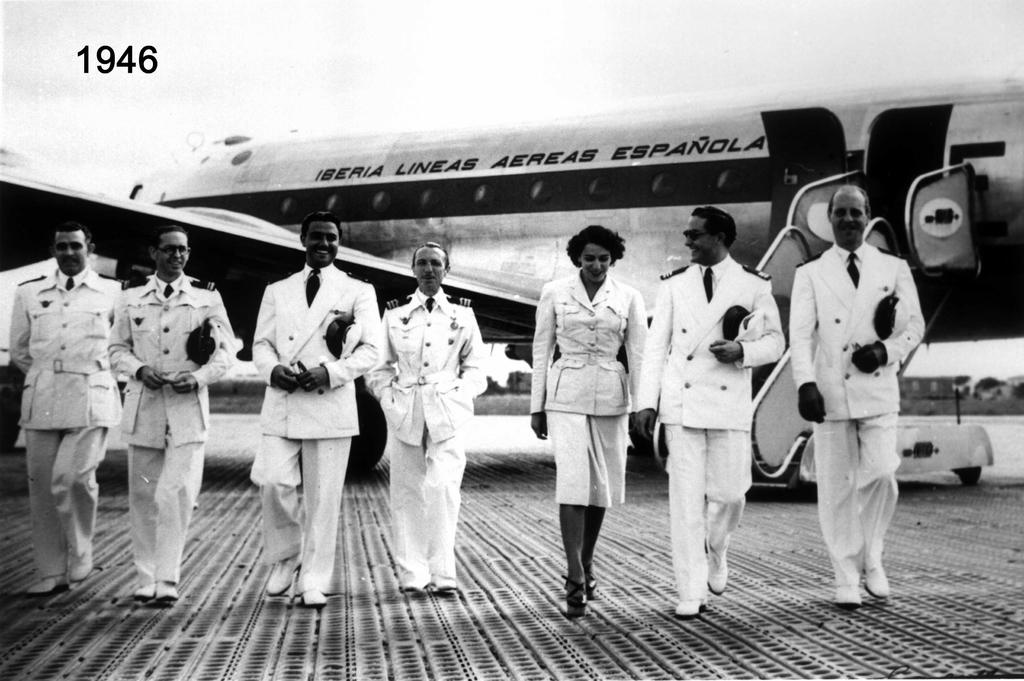What is happening in the image involving a group of people? There is a group of people in the image, and they are walking on the floor. What are the occupations of the people in the image? The people in the image are pilots. What can be seen in the background of the image? There are airplanes visible at the top of the image. How many sisters are present in the image? There is no mention of sisters in the image, as the people in the image are pilots. Are any of the pilots wearing a skirt in the image? There is no mention of skirts in the image, as the focus is on the pilots and their occupation. 